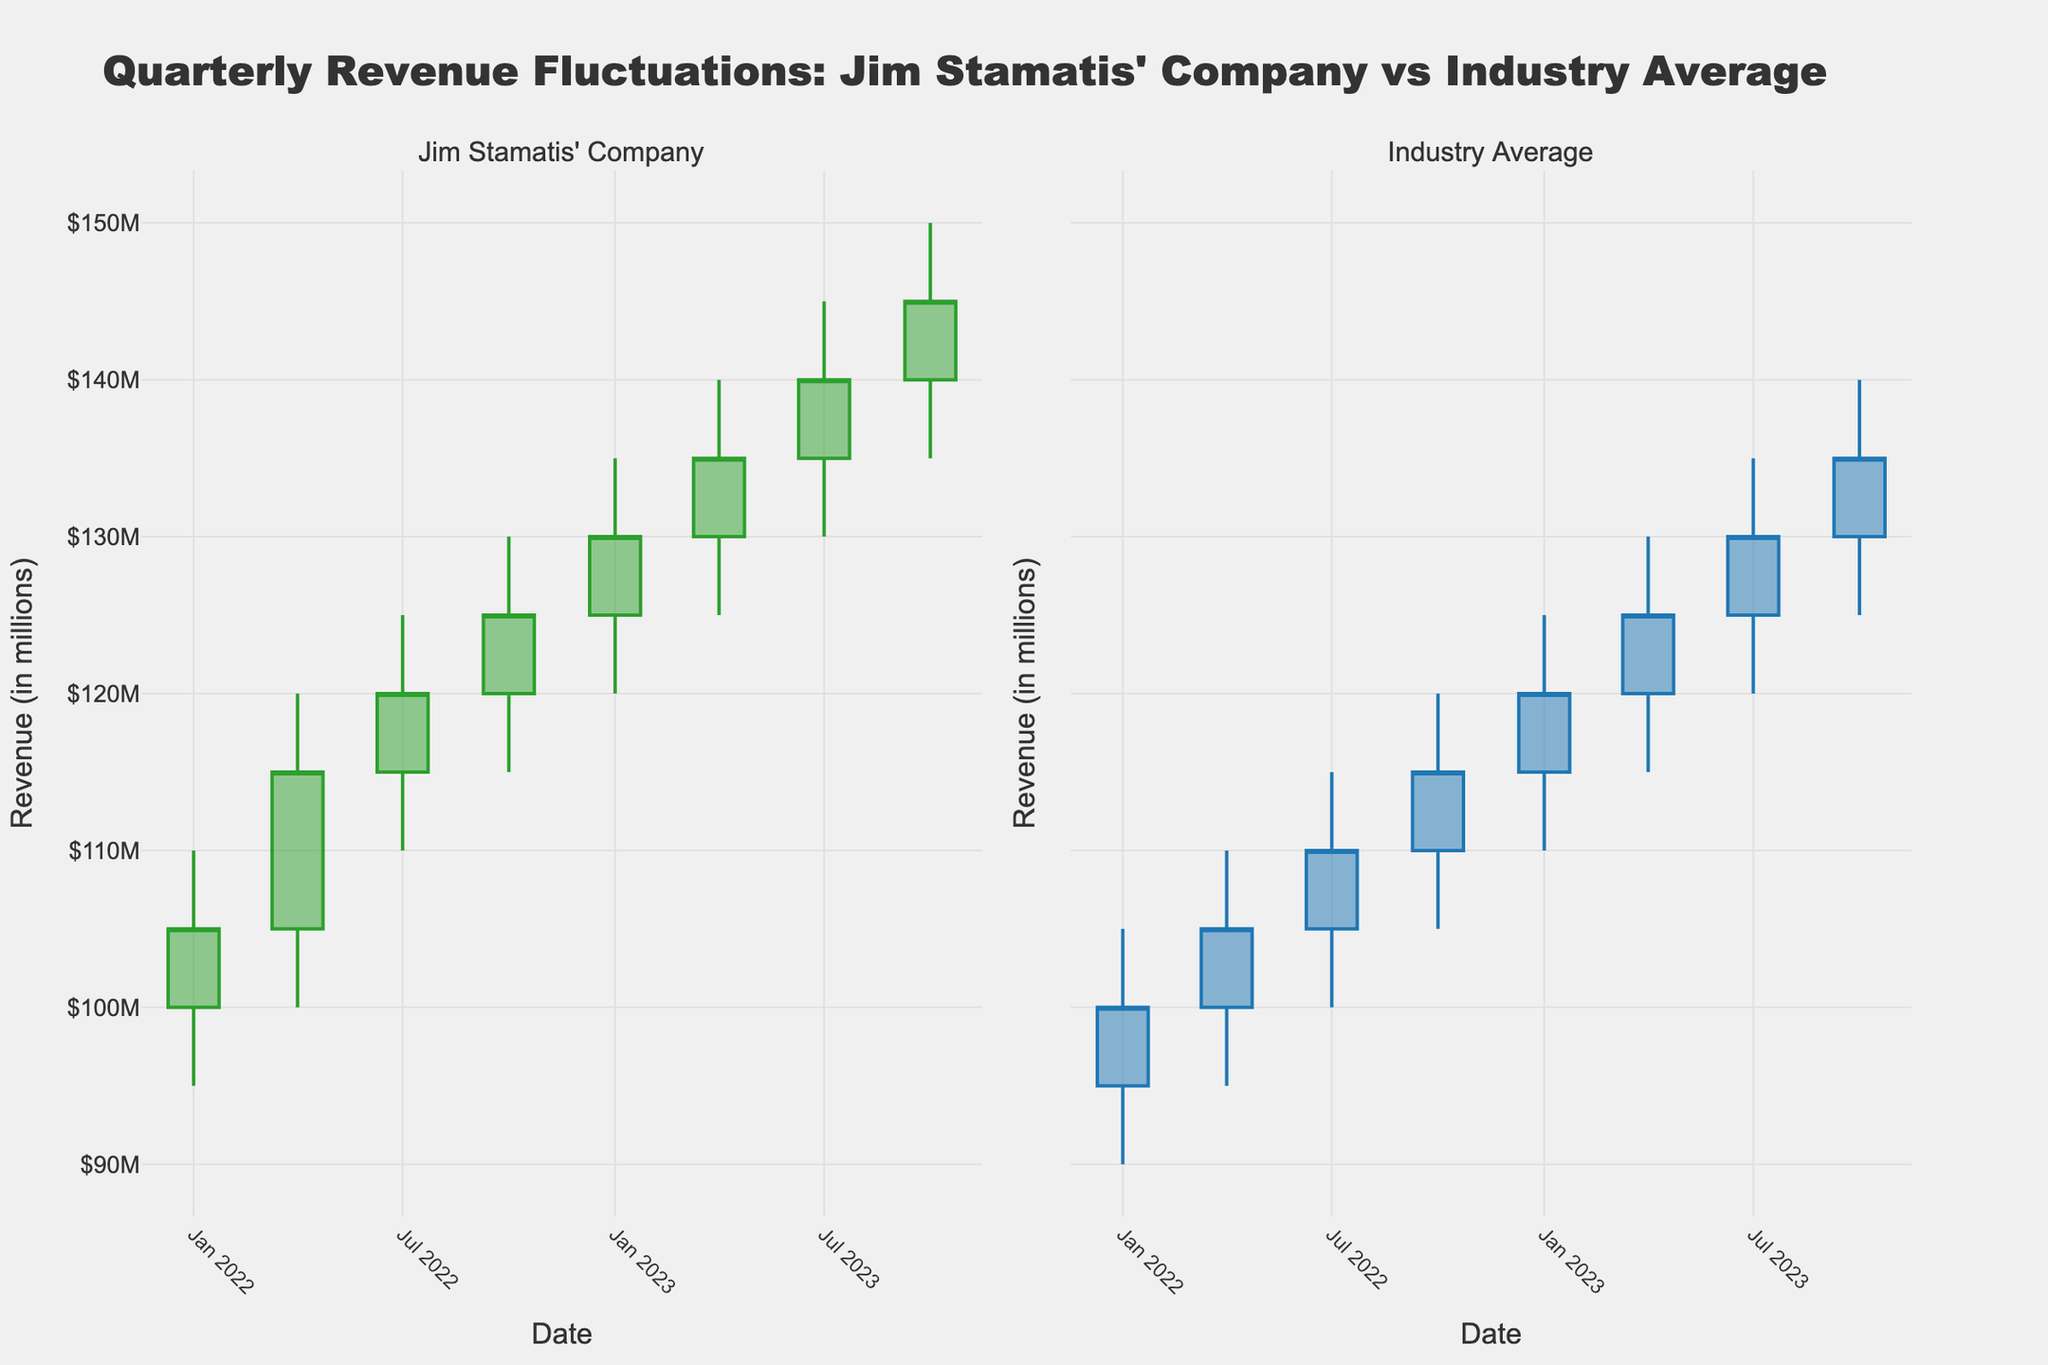What is the highest revenue for Jim Stamatis' Company in the time period shown? The highest revenue is represented by the highest 'High' value in Jim Stamatis' Company's candlestick plot, which is $150M in October 2023.
Answer: $150M What is the overall trend of quarterly revenue for Jim Stamatis' Company? The quarterly revenue shows a positive trend, with the 'Close' values increasing consistently from $105M in January 2022 to $145M in October 2023.
Answer: Positive trend Which quarter shows the smallest range of revenue for the Industry Average? The range of revenue for each quarter is the difference between the 'High' and 'Low' values. The smallest range is in October 2022 with a range of $120M - $105M = $15M.
Answer: October 2022 How does the Q1 2023 closing revenue of Jim Stamatis' Company compare to the Industry Average? In Q1 2023, the closing revenue for Jim Stamatis' Company is $130M, while for the Industry Average it is $120M. Therefore, Jim Stamatis' Company's closing revenue is $10M higher.
Answer: Higher by $10M What is a key difference in the revenue fluctuation patterns between Jim Stamatis' Company and the Industry Average? Jim Stamatis' Company shows consistent revenue growth each quarter, whereas the Industry Average grows at a slower pace.
Answer: Consistent growth vs slower pace In which quarter did both Jim Stamatis' Company and the Industry Average have their highest closing revenues? Both Jim Stamatis' Company and the Industry Average have their highest closing revenues in October 2023.
Answer: October 2023 Calculate the average closing revenue for Jim Stamatis' Company over the period. Sum of quarterly closing revenues for Jim Stamatis' Company is $105M + $115M + $120M + $125M + $130M + $135M + $140M + $145M = $1015M. There are 8 quarters, so the average is $1015M / 8 = $126.875M.
Answer: $126.875M Identify the quarter with the greatest closing revenue increase for Jim Stamatis' Company. The greatest increase is from Q2 2022 to Q3 2022, with a rise from $115M to $120M, an increase of $5M.
Answer: Q3 2022 